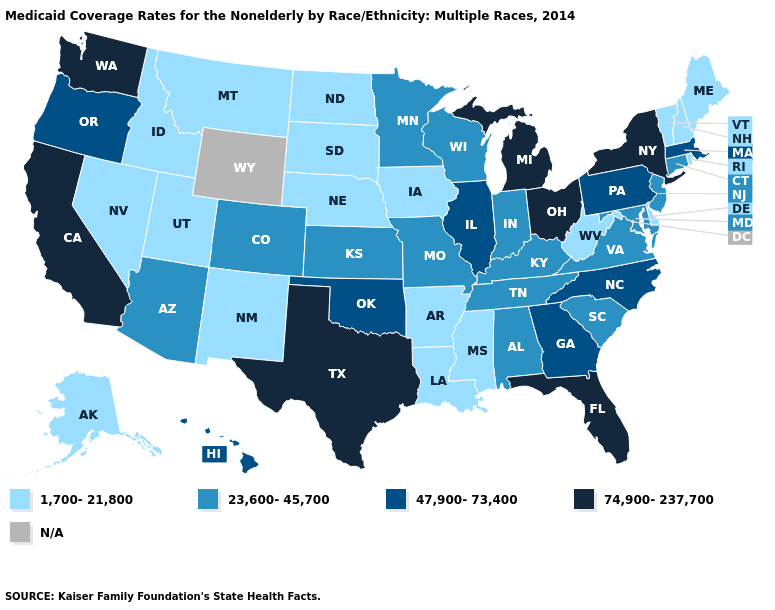What is the value of Oklahoma?
Answer briefly. 47,900-73,400. Does Maine have the lowest value in the Northeast?
Write a very short answer. Yes. What is the lowest value in the USA?
Keep it brief. 1,700-21,800. How many symbols are there in the legend?
Be succinct. 5. Does Idaho have the lowest value in the West?
Keep it brief. Yes. Which states hav the highest value in the Northeast?
Write a very short answer. New York. Does Minnesota have the highest value in the MidWest?
Keep it brief. No. What is the value of New Mexico?
Write a very short answer. 1,700-21,800. Among the states that border New Jersey , does New York have the highest value?
Short answer required. Yes. Name the states that have a value in the range N/A?
Answer briefly. Wyoming. Which states have the highest value in the USA?
Short answer required. California, Florida, Michigan, New York, Ohio, Texas, Washington. Which states hav the highest value in the MidWest?
Keep it brief. Michigan, Ohio. Does North Carolina have the highest value in the USA?
Give a very brief answer. No. 